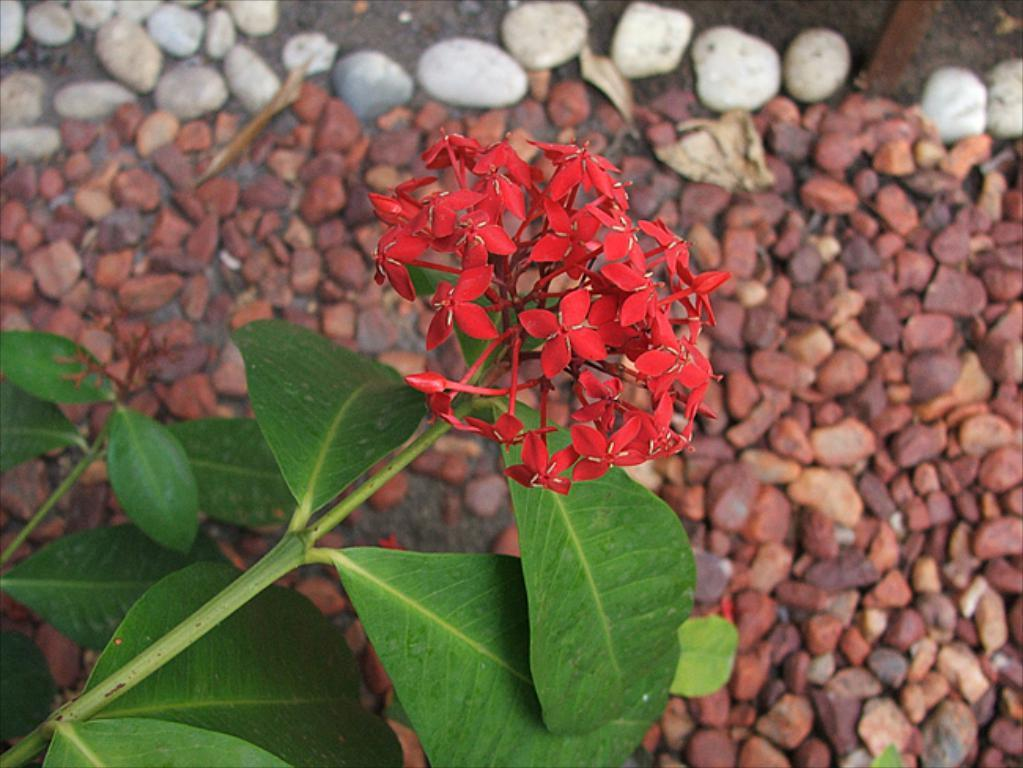What type of plants can be seen in the image? There are flowers in the image. What else can be seen in the image related to the plants? There are leaves in the image. What type of inanimate objects can be seen on the ground in the image? There are stones on the ground in the image. What type of cushion can be seen floating on the water in the image? There is no cushion or water present in the image; it features flowers, leaves, and stones on the ground. How many boats are visible in the image? There are no boats visible in the image. 